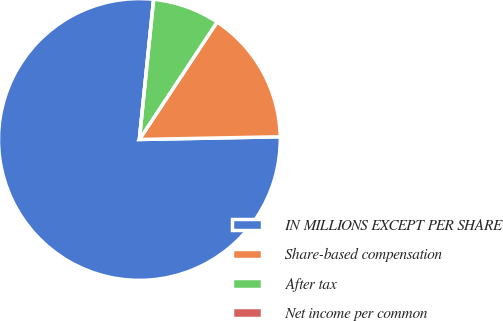Convert chart to OTSL. <chart><loc_0><loc_0><loc_500><loc_500><pie_chart><fcel>IN MILLIONS EXCEPT PER SHARE<fcel>Share-based compensation<fcel>After tax<fcel>Net income per common<nl><fcel>76.92%<fcel>15.39%<fcel>7.69%<fcel>0.0%<nl></chart> 